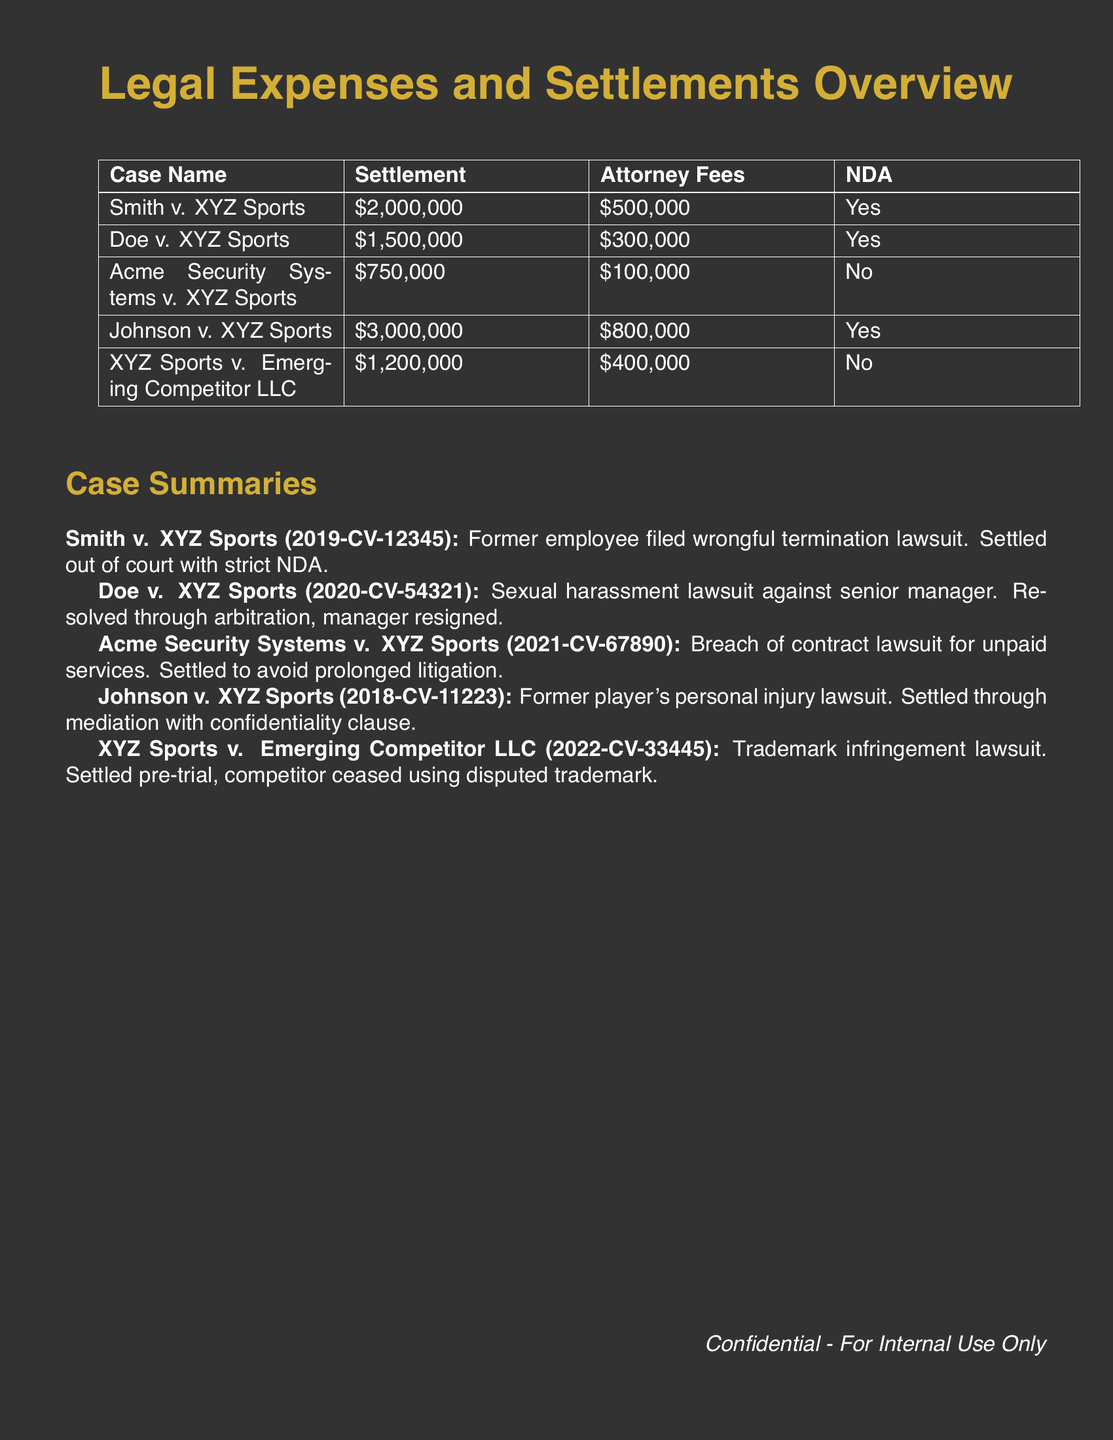What is the total settlement amount in the document? The total settlement amount is calculated by adding all individual settlements listed in the table: 2,000,000 + 1,500,000 + 750,000 + 3,000,000 + 1,200,000 = 8,450,000.
Answer: 8,450,000 How much was spent on attorney fees for Johnson v. XYZ Sports? The attorney fees for Johnson v. XYZ Sports are specified in the table as 800,000.
Answer: 800,000 Is there a non-disclosure agreement for Doe v. XYZ Sports? The table indicates whether there is an NDA for each case. For Doe v. XYZ Sports, the answer is Yes.
Answer: Yes How many cases listed resulted in a non-disclosure agreement? The cases with an NDA are Smith, Doe, and Johnson, totaling three cases.
Answer: 3 What was the settlement amount for Acme Security Systems v. XYZ Sports? The settlement amount for Acme Security Systems v. XYZ Sports is provided as 750,000.
Answer: 750,000 Which case had the highest attorney fees? By comparing the attorney fees of all cases, Johnson v. XYZ Sports has the highest fees at 800,000.
Answer: Johnson v. XYZ Sports What year was the Johnson v. XYZ Sports case filed? The summary states that Johnson v. XYZ Sports was filed in 2018 as indicated in the case details.
Answer: 2018 What type of lawsuit was filed in Smith v. XYZ Sports? The summary describes it as a wrongful termination lawsuit.
Answer: Wrongful termination 